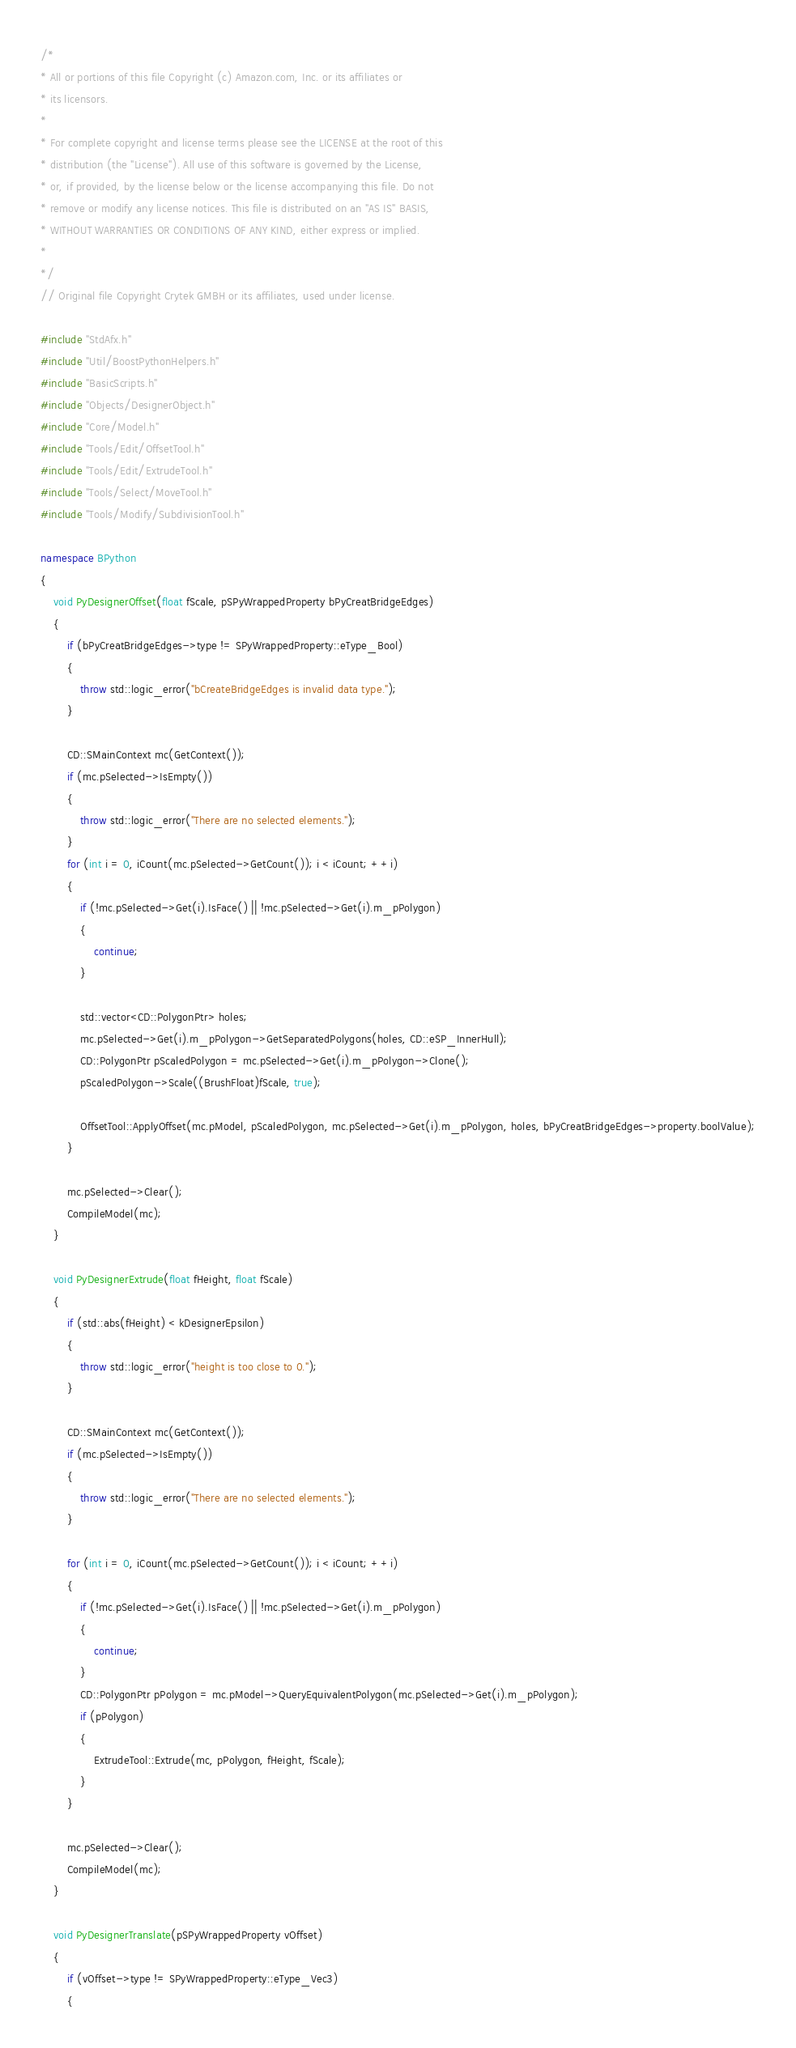<code> <loc_0><loc_0><loc_500><loc_500><_C++_>/*
* All or portions of this file Copyright (c) Amazon.com, Inc. or its affiliates or
* its licensors.
*
* For complete copyright and license terms please see the LICENSE at the root of this
* distribution (the "License"). All use of this software is governed by the License,
* or, if provided, by the license below or the license accompanying this file. Do not
* remove or modify any license notices. This file is distributed on an "AS IS" BASIS,
* WITHOUT WARRANTIES OR CONDITIONS OF ANY KIND, either express or implied.
*
*/
// Original file Copyright Crytek GMBH or its affiliates, used under license.

#include "StdAfx.h"
#include "Util/BoostPythonHelpers.h"
#include "BasicScripts.h"
#include "Objects/DesignerObject.h"
#include "Core/Model.h"
#include "Tools/Edit/OffsetTool.h"
#include "Tools/Edit/ExtrudeTool.h"
#include "Tools/Select/MoveTool.h"
#include "Tools/Modify/SubdivisionTool.h"

namespace BPython
{
    void PyDesignerOffset(float fScale, pSPyWrappedProperty bPyCreatBridgeEdges)
    {
        if (bPyCreatBridgeEdges->type != SPyWrappedProperty::eType_Bool)
        {
            throw std::logic_error("bCreateBridgeEdges is invalid data type.");
        }

        CD::SMainContext mc(GetContext());
        if (mc.pSelected->IsEmpty())
        {
            throw std::logic_error("There are no selected elements.");
        }
        for (int i = 0, iCount(mc.pSelected->GetCount()); i < iCount; ++i)
        {
            if (!mc.pSelected->Get(i).IsFace() || !mc.pSelected->Get(i).m_pPolygon)
            {
                continue;
            }

            std::vector<CD::PolygonPtr> holes;
            mc.pSelected->Get(i).m_pPolygon->GetSeparatedPolygons(holes, CD::eSP_InnerHull);
            CD::PolygonPtr pScaledPolygon = mc.pSelected->Get(i).m_pPolygon->Clone();
            pScaledPolygon->Scale((BrushFloat)fScale, true);

            OffsetTool::ApplyOffset(mc.pModel, pScaledPolygon, mc.pSelected->Get(i).m_pPolygon, holes, bPyCreatBridgeEdges->property.boolValue);
        }

        mc.pSelected->Clear();
        CompileModel(mc);
    }

    void PyDesignerExtrude(float fHeight, float fScale)
    {
        if (std::abs(fHeight) < kDesignerEpsilon)
        {
            throw std::logic_error("height is too close to 0.");
        }

        CD::SMainContext mc(GetContext());
        if (mc.pSelected->IsEmpty())
        {
            throw std::logic_error("There are no selected elements.");
        }

        for (int i = 0, iCount(mc.pSelected->GetCount()); i < iCount; ++i)
        {
            if (!mc.pSelected->Get(i).IsFace() || !mc.pSelected->Get(i).m_pPolygon)
            {
                continue;
            }
            CD::PolygonPtr pPolygon = mc.pModel->QueryEquivalentPolygon(mc.pSelected->Get(i).m_pPolygon);
            if (pPolygon)
            {
                ExtrudeTool::Extrude(mc, pPolygon, fHeight, fScale);
            }
        }

        mc.pSelected->Clear();
        CompileModel(mc);
    }

    void PyDesignerTranslate(pSPyWrappedProperty vOffset)
    {
        if (vOffset->type != SPyWrappedProperty::eType_Vec3)
        {</code> 